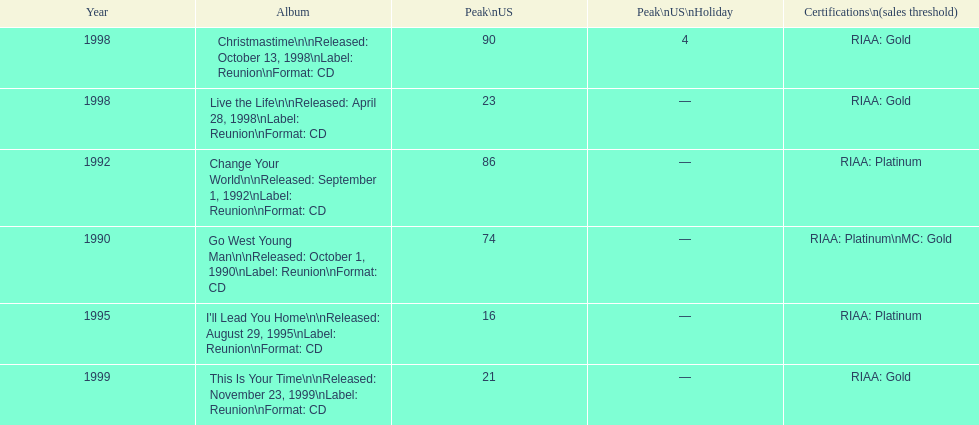What was the first michael w smith album? Go West Young Man. Give me the full table as a dictionary. {'header': ['Year', 'Album', 'Peak\\nUS', 'Peak\\nUS\\nHoliday', 'Certifications\\n(sales threshold)'], 'rows': [['1998', 'Christmastime\\n\\nReleased: October 13, 1998\\nLabel: Reunion\\nFormat: CD', '90', '4', 'RIAA: Gold'], ['1998', 'Live the Life\\n\\nReleased: April 28, 1998\\nLabel: Reunion\\nFormat: CD', '23', '—', 'RIAA: Gold'], ['1992', 'Change Your World\\n\\nReleased: September 1, 1992\\nLabel: Reunion\\nFormat: CD', '86', '—', 'RIAA: Platinum'], ['1990', 'Go West Young Man\\n\\nReleased: October 1, 1990\\nLabel: Reunion\\nFormat: CD', '74', '—', 'RIAA: Platinum\\nMC: Gold'], ['1995', "I'll Lead You Home\\n\\nReleased: August 29, 1995\\nLabel: Reunion\\nFormat: CD", '16', '—', 'RIAA: Platinum'], ['1999', 'This Is Your Time\\n\\nReleased: November 23, 1999\\nLabel: Reunion\\nFormat: CD', '21', '—', 'RIAA: Gold']]} 